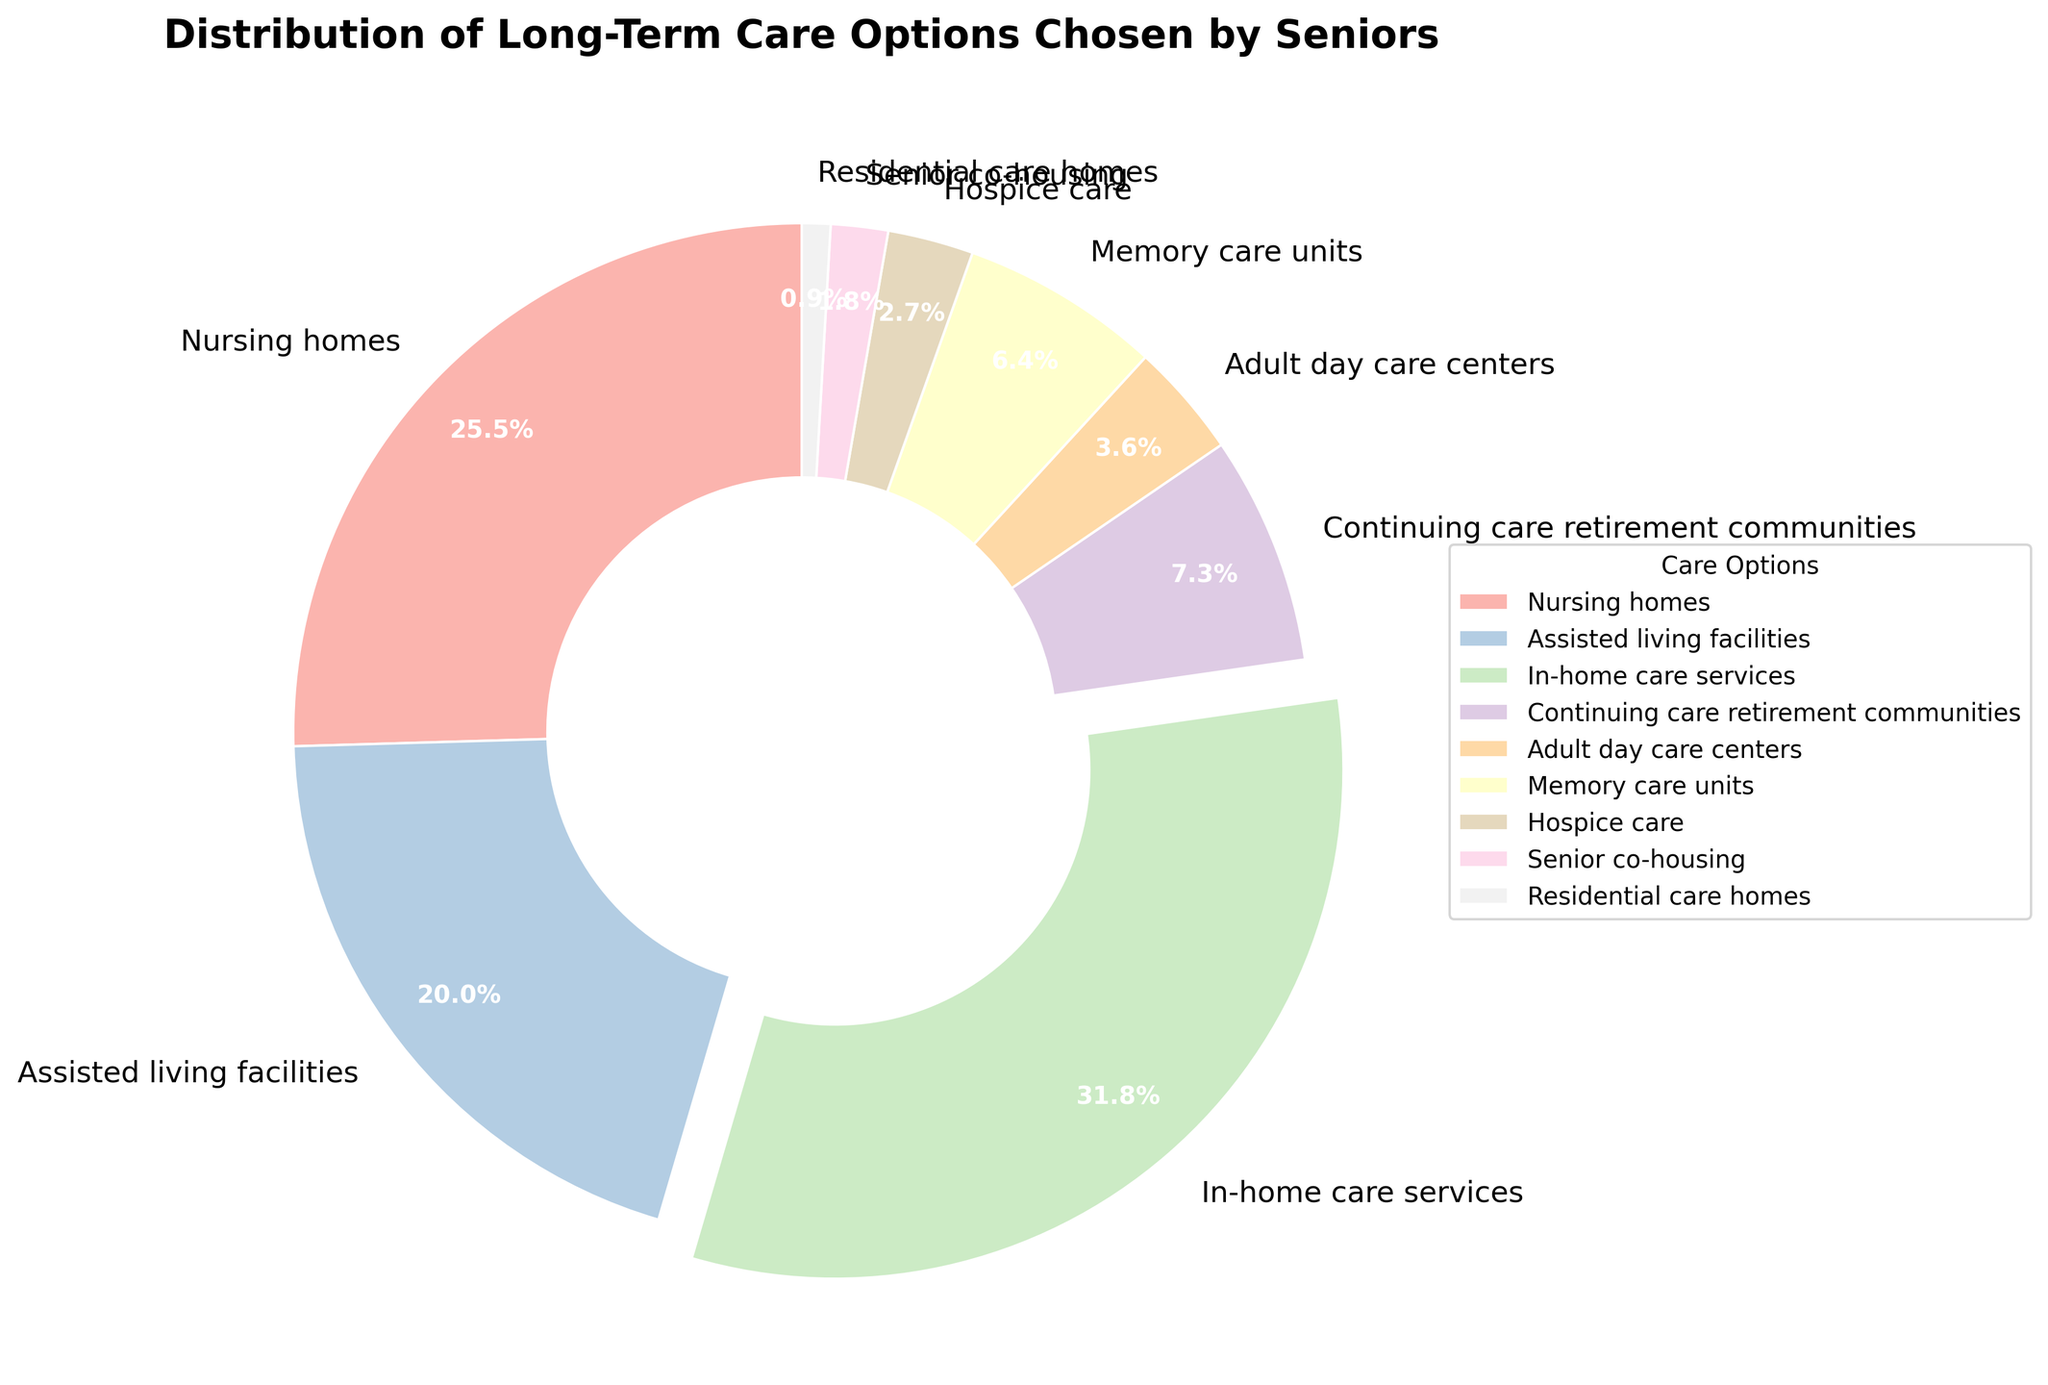How many more seniors prefer in-home care services compared to assisted living facilities? To find the difference, subtract the percentage of seniors choosing assisted living facilities from those choosing in-home care services: 35% - 22% = 13%.
Answer: 13% Which long-term care option is chosen by the least number of seniors, and what is its percentage? The segment representing Residential care homes is the smallest, with a percentage of 1%.
Answer: Residential care homes, 1% What is the combined percentage of seniors choosing adult day care centers and memory care units? Add the percentages for adult day care centers and memory care units: 4% + 7% = 11%.
Answer: 11% Which care option has the highest percentage and what distinguishing visual feature does it have? In-home care services have the highest percentage at 35%, and its segment is slightly separated from the rest of the pie chart (exploded segment).
Answer: In-home care services, exploded segment Are there more seniors in continuing care retirement communities or memory care units? Compare the percentages of continuing care retirement communities (8%) and memory care units (7%). 8% > 7%, so there are more seniors in continuing care retirement communities.
Answer: Continuing care retirement communities What percentage of seniors choose either nursing homes or assisted living facilities? Sum the percentages of nursing homes and assisted living facilities: 28% + 22% = 50%.
Answer: 50% Which care option is selected by a percentage of seniors that is less than 5%? Options with percentages less than 5% are Adult day care centers (4%), Hospice care (3%), Senior co-housing (2%), and Residential care homes (1%).
Answer: Adult day care centers, Hospice care, Senior co-housing, Residential care homes What is the average percentage of the three least chosen care options? The three least chosen options are Residential care homes (1%), Senior co-housing (2%), and Hospice care (3%). Average = (1% + 2% + 3%) / 3 = 6% / 3 = 2%.
Answer: 2% How many segments in the pie chart have a title below their percentage? Inspect visually: All segments have their titles placed below their percentage labels. This applies to all 9 segments.
Answer: 9 